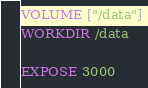<code> <loc_0><loc_0><loc_500><loc_500><_Dockerfile_>
VOLUME ["/data"]
WORKDIR /data

EXPOSE 3000</code> 